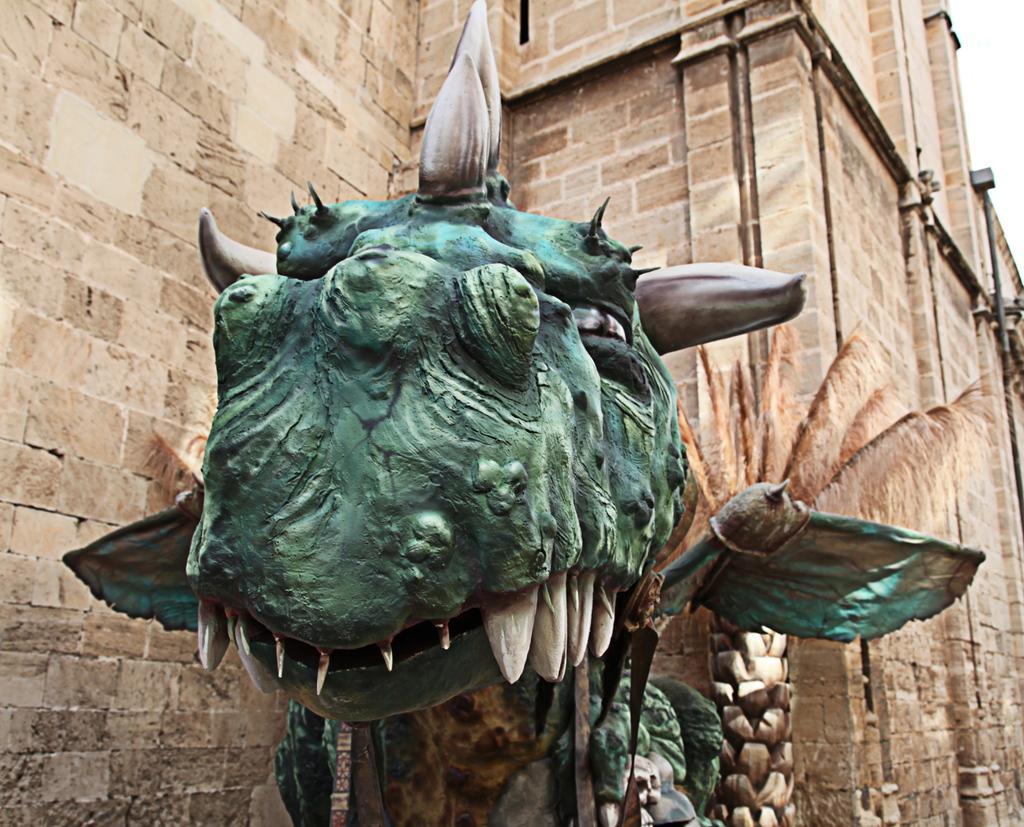Describe this image in one or two sentences. In this image there is a dragon statue in the middle. In the background there is a wall. On the right side there is a dry palm tree beside the wall. 